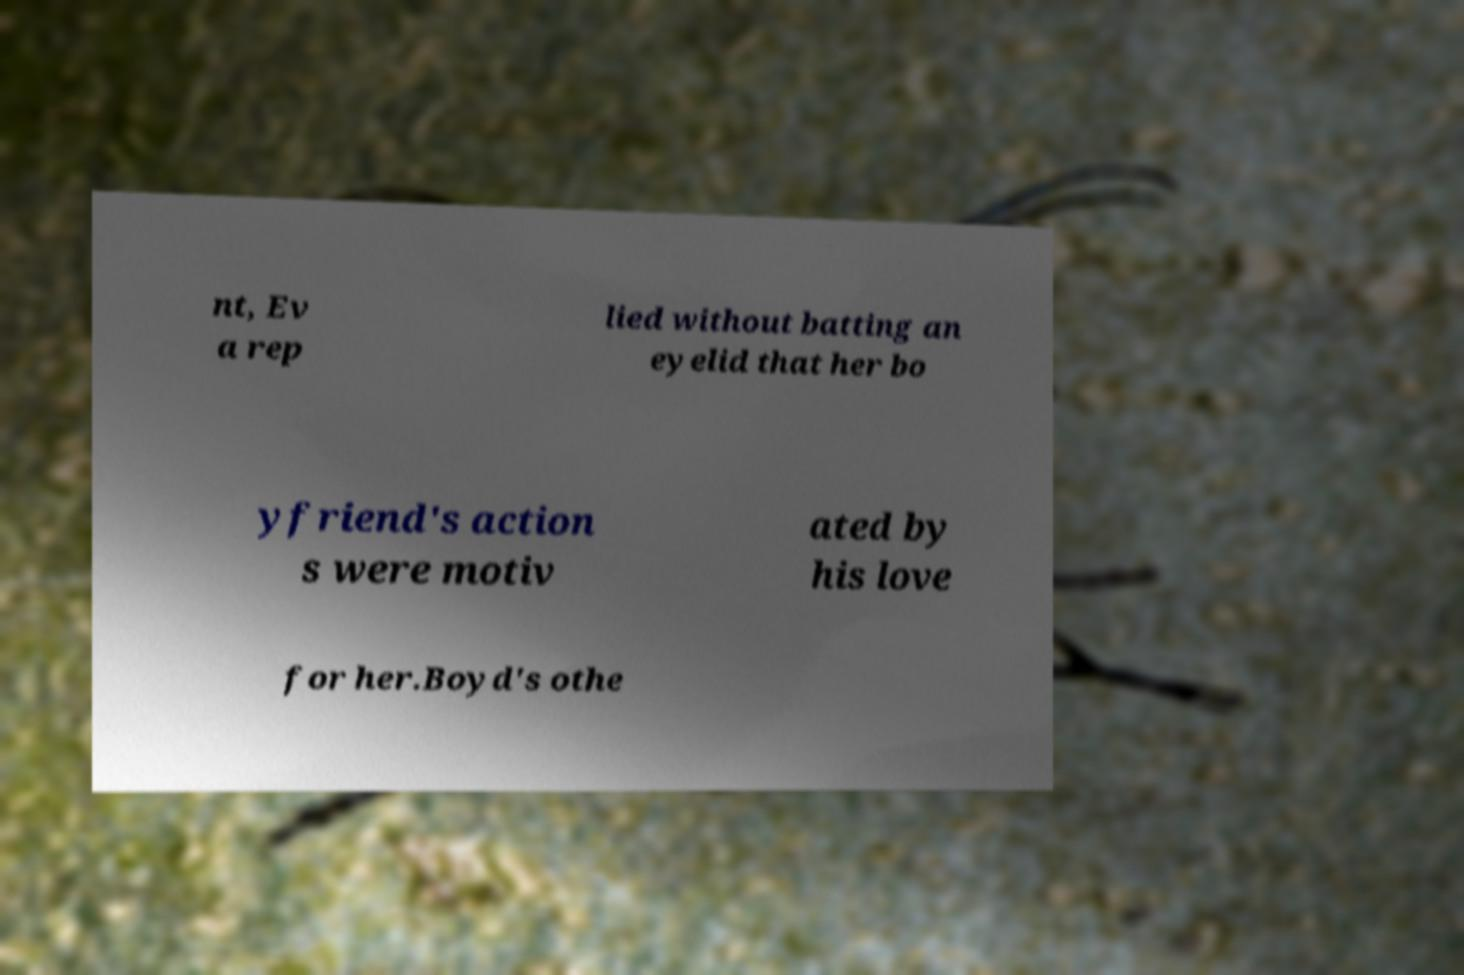I need the written content from this picture converted into text. Can you do that? nt, Ev a rep lied without batting an eyelid that her bo yfriend's action s were motiv ated by his love for her.Boyd's othe 